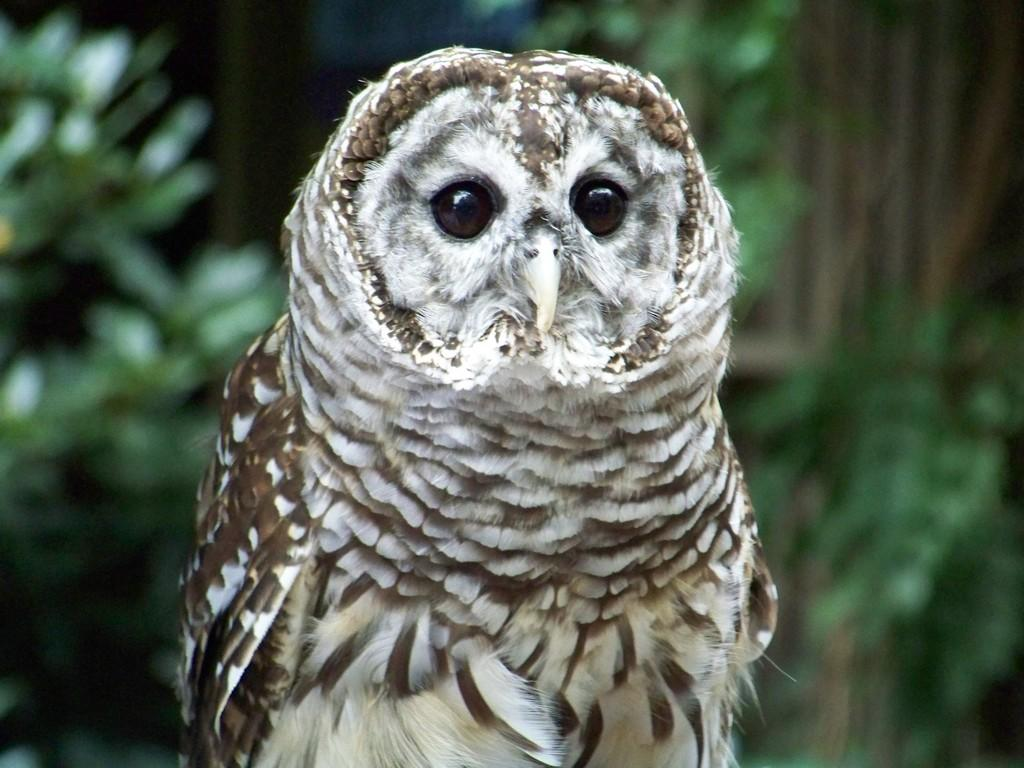What animal is present in the image? There is an owl in the image. What can be seen in the background of the image? There are many trees in the background of the image. Can you read the note that the squirrel is holding in the image? There is no squirrel or note present in the image; it only features an owl and trees in the background. 